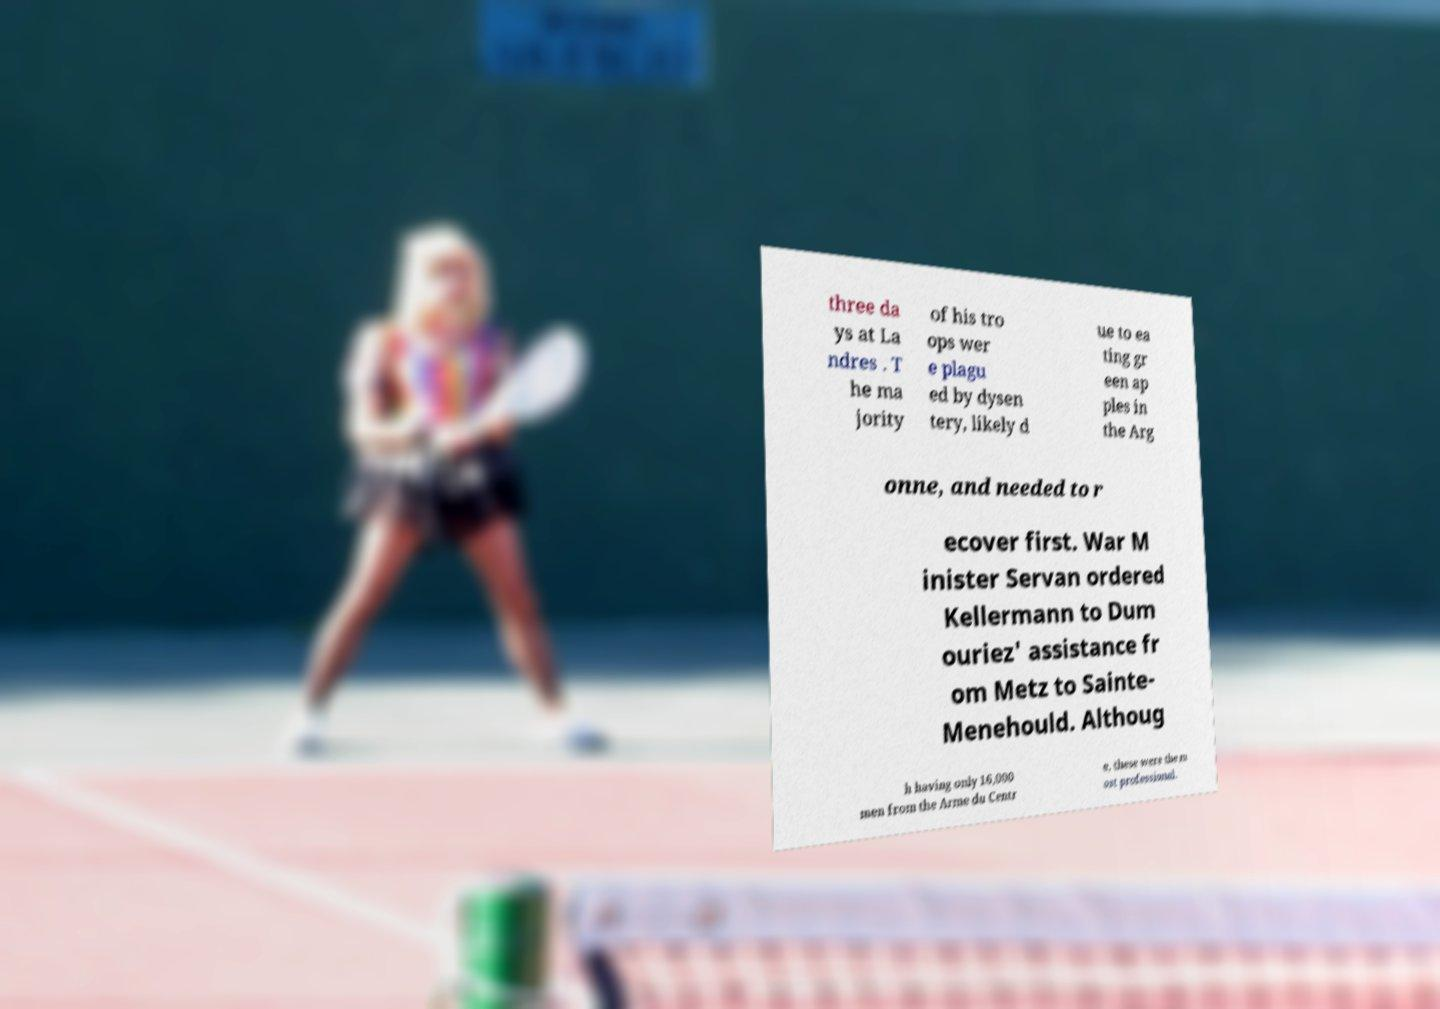Could you extract and type out the text from this image? three da ys at La ndres . T he ma jority of his tro ops wer e plagu ed by dysen tery, likely d ue to ea ting gr een ap ples in the Arg onne, and needed to r ecover first. War M inister Servan ordered Kellermann to Dum ouriez' assistance fr om Metz to Sainte- Menehould. Althoug h having only 16,000 men from the Arme du Centr e, these were the m ost professional. 